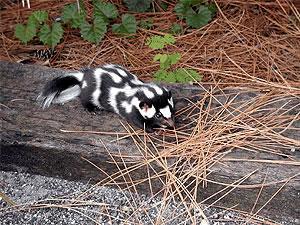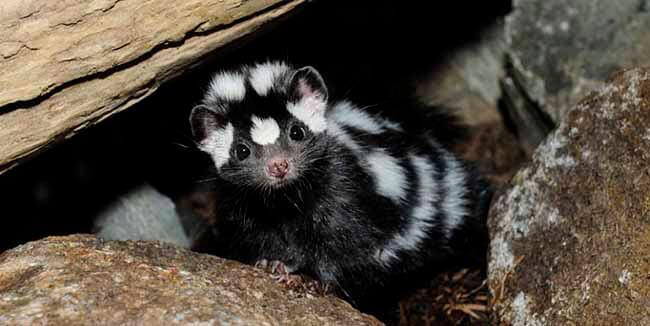The first image is the image on the left, the second image is the image on the right. Given the left and right images, does the statement "There is a skunk coming out from under a fallen tree log" hold true? Answer yes or no. Yes. 